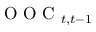<formula> <loc_0><loc_0><loc_500><loc_500>O O C _ { t , t - 1 }</formula> 